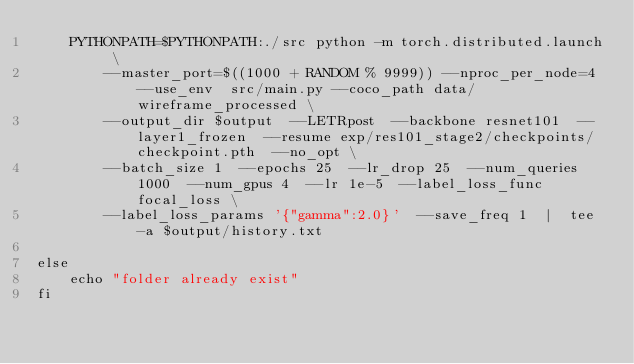Convert code to text. <code><loc_0><loc_0><loc_500><loc_500><_Bash_>    PYTHONPATH=$PYTHONPATH:./src python -m torch.distributed.launch \
        --master_port=$((1000 + RANDOM % 9999)) --nproc_per_node=4 --use_env  src/main.py --coco_path data/wireframe_processed \
        --output_dir $output  --LETRpost  --backbone resnet101  --layer1_frozen  --resume exp/res101_stage2/checkpoints/checkpoint.pth  --no_opt \
        --batch_size 1  --epochs 25  --lr_drop 25  --num_queries 1000  --num_gpus 4  --lr 1e-5  --label_loss_func focal_loss \
        --label_loss_params '{"gamma":2.0}'  --save_freq 1  |  tee -a $output/history.txt 

else
    echo "folder already exist"
fi



</code> 